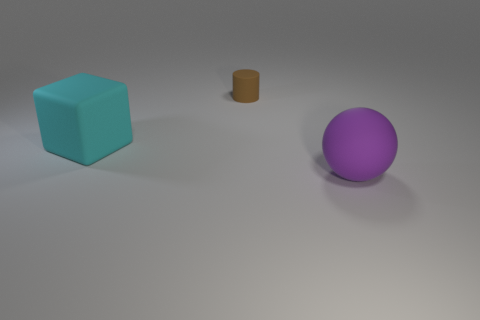Add 2 big cylinders. How many objects exist? 5 Subtract all cubes. How many objects are left? 2 Add 3 tiny rubber cylinders. How many tiny rubber cylinders exist? 4 Subtract 0 gray cylinders. How many objects are left? 3 Subtract all matte things. Subtract all blue rubber spheres. How many objects are left? 0 Add 2 large cyan things. How many large cyan things are left? 3 